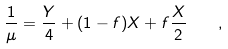<formula> <loc_0><loc_0><loc_500><loc_500>\frac { 1 } { \mu } = \frac { Y } { 4 } + ( 1 - f ) X + f \frac { X } { 2 } \quad ,</formula> 